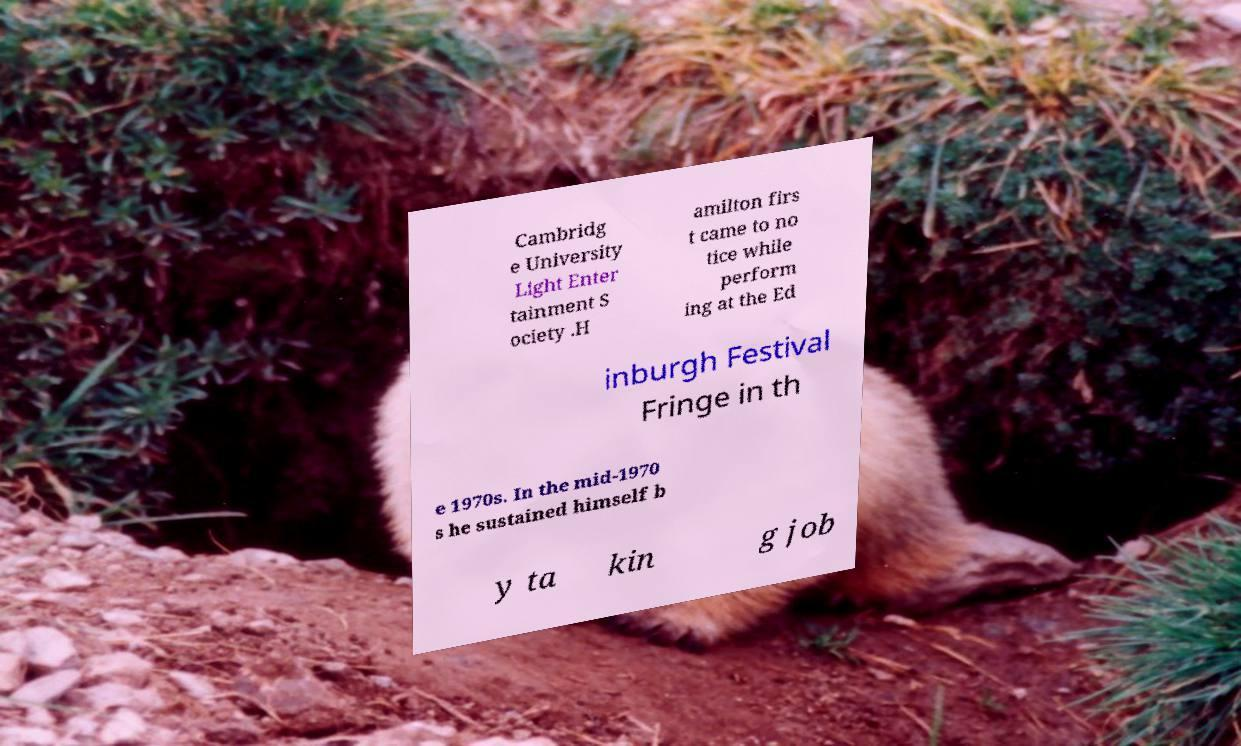Could you extract and type out the text from this image? Cambridg e University Light Enter tainment S ociety .H amilton firs t came to no tice while perform ing at the Ed inburgh Festival Fringe in th e 1970s. In the mid-1970 s he sustained himself b y ta kin g job 